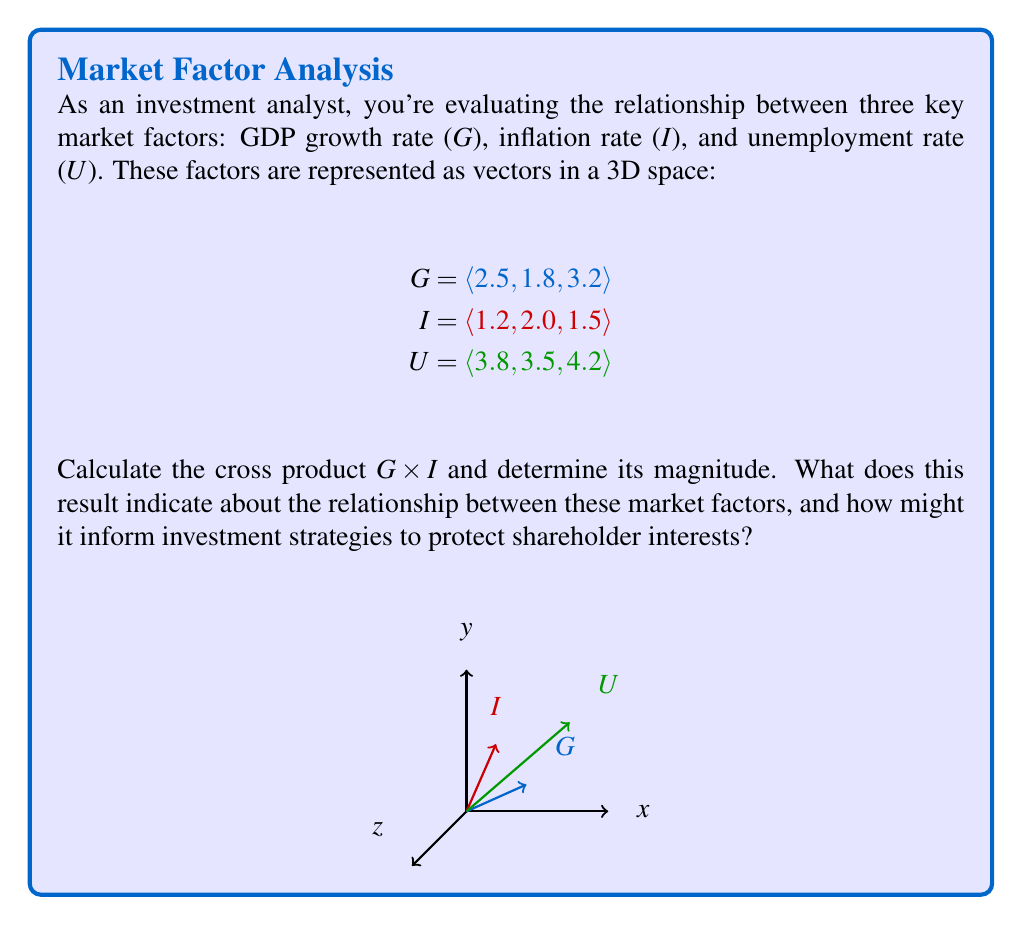Give your solution to this math problem. To solve this problem, we'll follow these steps:

1) First, let's compute the cross product G × I using the formula:

   G × I = $\langle (G_y I_z - G_z I_y), (G_z I_x - G_x I_z), (G_x I_y - G_y I_x) \rangle$

   G × I = $\langle (1.8 * 1.5 - 3.2 * 2.0), (3.2 * 1.2 - 2.5 * 1.5), (2.5 * 2.0 - 1.8 * 1.2) \rangle$
   
   G × I = $\langle -3.7, 0.84, 2.84 \rangle$

2) Now, let's calculate the magnitude of this cross product:

   $\|G \times I\| = \sqrt{(-3.7)^2 + (0.84)^2 + (2.84)^2}$
   
   $\|G \times I\| = \sqrt{13.69 + 0.7056 + 8.0656}$
   
   $\|G \times I\| = \sqrt{22.4612} \approx 4.74$

3) Interpretation:
   - The cross product G × I represents the vector perpendicular to both G and I.
   - Its magnitude (4.74) is equal to the area of the parallelogram formed by G and I.
   - A non-zero cross product indicates that G and I are not parallel, implying some level of independence between GDP growth and inflation rates.
   - The relatively large magnitude suggests a significant relationship between these factors.

4) Investment strategy implications:
   - The substantial magnitude indicates that changes in GDP growth and inflation rates could have significant combined effects on the market.
   - Investors should consider diversifying across sectors that respond differently to these economic indicators.
   - Shareholders' interests might be protected by balancing investments between growth-oriented stocks (benefiting from high GDP growth) and inflation-hedged assets.
   - The perpendicular nature of the cross product suggests monitoring for potential economic scenarios where GDP and inflation move in unexpected ways relative to each other.
Answer: $\|G \times I\| \approx 4.74$; indicates significant, non-parallel relationship between GDP growth and inflation, suggesting diversified investment strategy across growth stocks and inflation hedges. 